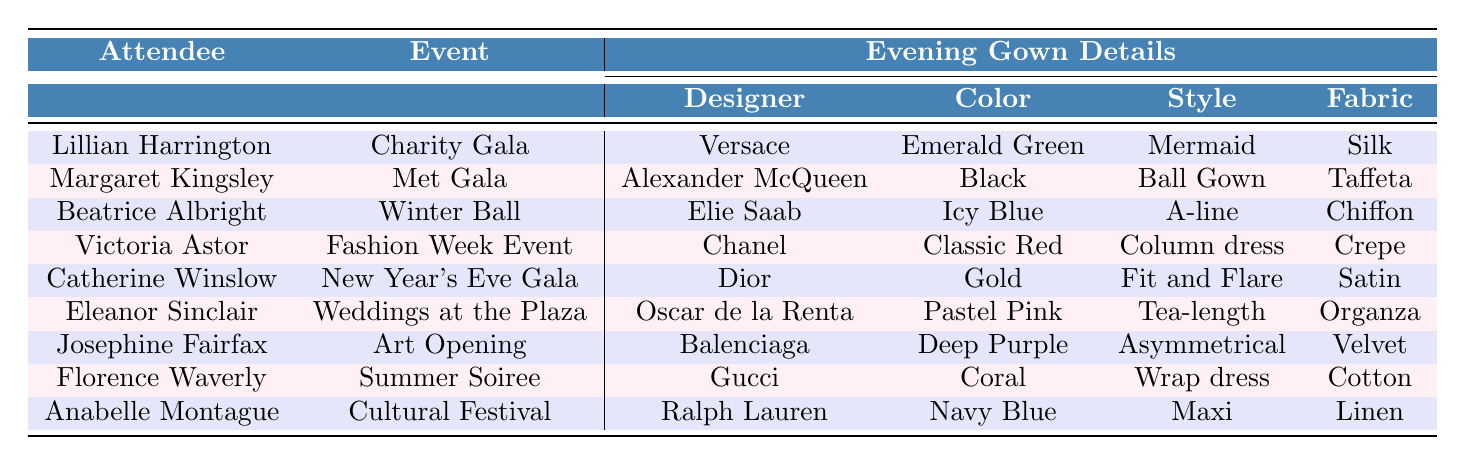What designer created the evening gown for Victoria Astor? By looking at the row for Victoria Astor in the table, I can see that her evening gown was designed by Chanel.
Answer: Chanel Which attendee wore a gown in Icy Blue color? Referring to the table, I find that Beatrice Albright wore an evening gown in Icy Blue color during the Winter Ball.
Answer: Beatrice Albright Is there an attendee who wore a gold evening gown? The table indicates that Catherine Winslow wore a gold evening gown at the New Year's Eve Gala, so the answer is yes.
Answer: Yes What style of gown did Josephine Fairfax wear? In the row for Josephine Fairfax, it specifies that she wore an Asymmetrical style gown for the Art Opening.
Answer: Asymmetrical How many attendees wore evening gowns by Oscar de la Renta? By checking the table, I see only one attendee, Eleanor Sinclair, wore an evening gown by Oscar de la Renta.
Answer: 1 Which event did Margaret Kingsley attend? The table shows that Margaret Kingsley attended the Met Gala.
Answer: Met Gala What is the color of the evening gown worn by Lillian Harrington? According to the table, Lillian Harrington wore an Emerald Green evening gown for the Charity Gala.
Answer: Emerald Green Which two attendees wore gowns made from velvet? Looking at the evening gown details, I see that only one attendee, Josephine Fairfax, wore an evening gown made from velvet. Therefore, the answer is Josephine Fairfax.
Answer: Josephine Fairfax Which designer is associated with the Fit and Flare style gown? Referring to the details in the table, I find that the Fit and Flare style gown was designed by Dior and worn by Catherine Winslow.
Answer: Dior What is the difference in gown styles between Margaret Kingsley and Eleanor Sinclair? Margaret Kingsley wore a Ball Gown, while Eleanor Sinclair wore a Tea-length gown. Therefore, the difference is between Ball Gown and Tea-length styles.
Answer: Ball Gown and Tea-length Are there more attendees with gowns in shades of blue or shades of pink? By examining the table, I see that Beatrice Albright wore an Icy Blue gown and Anabelle Montague wore a Navy Blue gown, while Eleanor Sinclair wore a Pastel Pink gown. Therefore, there are more blue gowns (2) compared to pink gowns (1).
Answer: More blue gowns What is the total number of unique gown styles represented at the events? By reviewing the table, the unique styles are: Mermaid, Ball Gown, A-line, Column dress, Fit and Flare, Tea-length, Asymmetrical, Wrap dress, and Maxi. That counts to a total of 9 unique gown styles.
Answer: 9 Which attendee has the most colorful gown based on the color names in the table? Analyzing the color names, "Emerald Green", "Icy Blue", "Classic Red", "Gold", "Pastel Pink", "Deep Purple", "Coral", "Navy Blue" - the most colorful would be subjective, but I determine that the Coral gown worn by Florence Waverly stands out as a vibrant color.
Answer: Coral (Florence Waverly) What is the total number of events listed in the table? There are 9 distinct events mentioned in the table, one for each attendee.
Answer: 9 